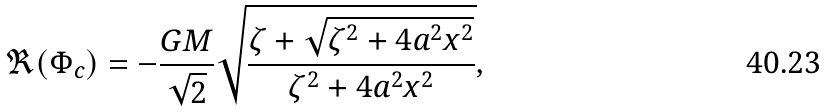<formula> <loc_0><loc_0><loc_500><loc_500>\Re ( \Phi _ { c } ) = - \frac { G M } { \sqrt { 2 } } \sqrt { \frac { \zeta + \sqrt { \zeta ^ { 2 } + 4 a ^ { 2 } x ^ { 2 } } } { \zeta ^ { 2 } + 4 a ^ { 2 } x ^ { 2 } } } ,</formula> 